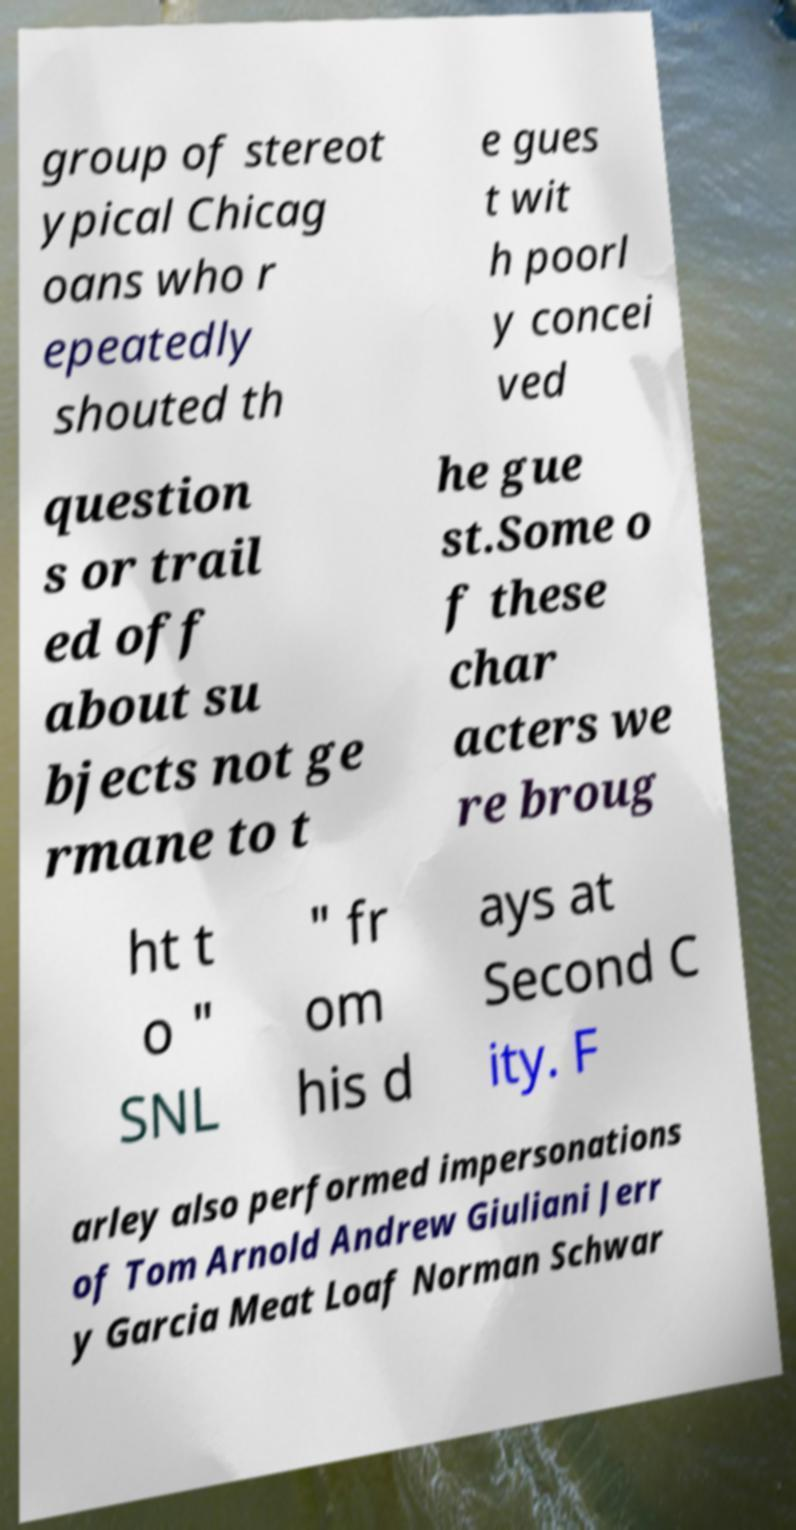Can you read and provide the text displayed in the image?This photo seems to have some interesting text. Can you extract and type it out for me? group of stereot ypical Chicag oans who r epeatedly shouted th e gues t wit h poorl y concei ved question s or trail ed off about su bjects not ge rmane to t he gue st.Some o f these char acters we re broug ht t o " SNL " fr om his d ays at Second C ity. F arley also performed impersonations of Tom Arnold Andrew Giuliani Jerr y Garcia Meat Loaf Norman Schwar 